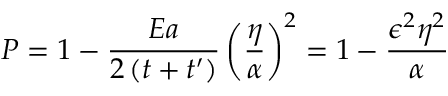Convert formula to latex. <formula><loc_0><loc_0><loc_500><loc_500>P = 1 - \frac { E a } { 2 \left ( t + t ^ { \prime } \right ) } \left ( \frac { \eta } { \alpha } \right ) ^ { 2 } = 1 - \frac { \epsilon ^ { 2 } \eta ^ { 2 } } { \alpha }</formula> 